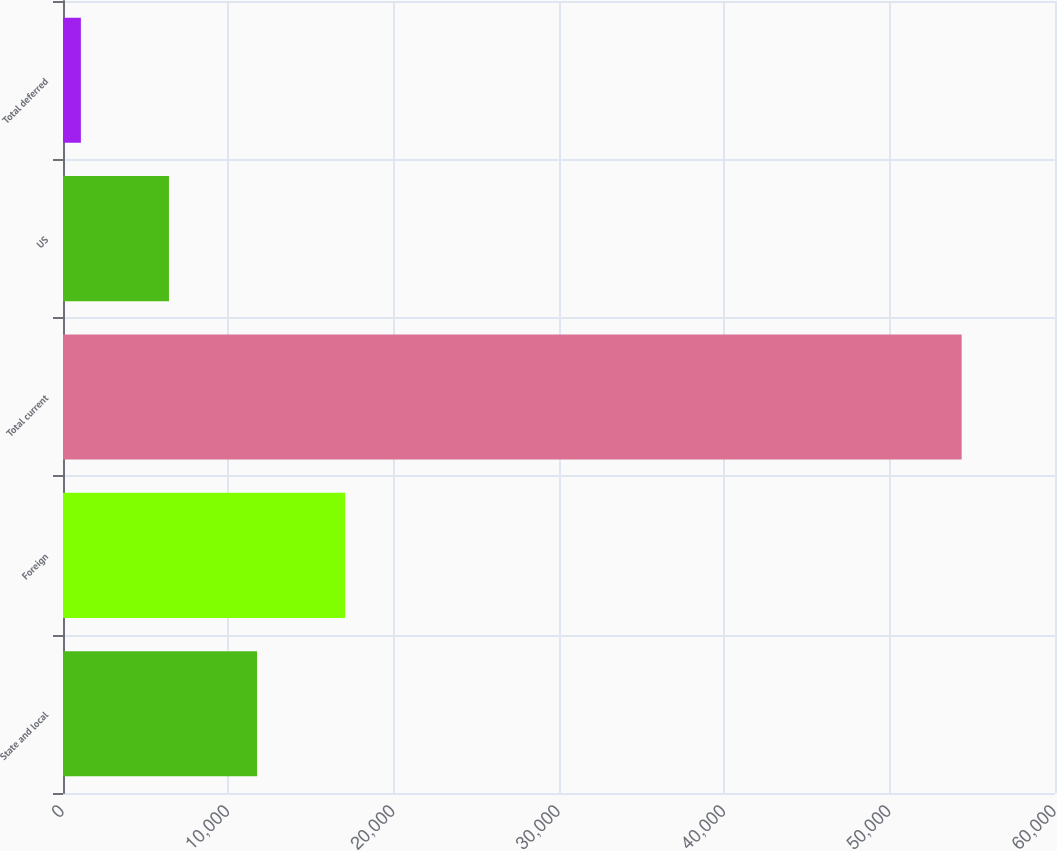Convert chart to OTSL. <chart><loc_0><loc_0><loc_500><loc_500><bar_chart><fcel>State and local<fcel>Foreign<fcel>Total current<fcel>US<fcel>Total deferred<nl><fcel>11735.8<fcel>17063.2<fcel>54355<fcel>6408.4<fcel>1081<nl></chart> 